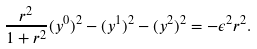<formula> <loc_0><loc_0><loc_500><loc_500>\frac { r ^ { 2 } } { 1 + r ^ { 2 } } ( y ^ { 0 } ) ^ { 2 } - ( y ^ { 1 } ) ^ { 2 } - ( y ^ { 2 } ) ^ { 2 } = - \epsilon ^ { 2 } r ^ { 2 } .</formula> 